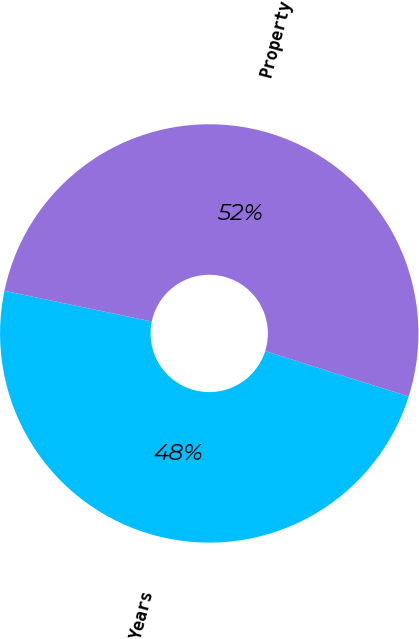Convert chart to OTSL. <chart><loc_0><loc_0><loc_500><loc_500><pie_chart><fcel>Years<fcel>Property<nl><fcel>48.39%<fcel>51.61%<nl></chart> 